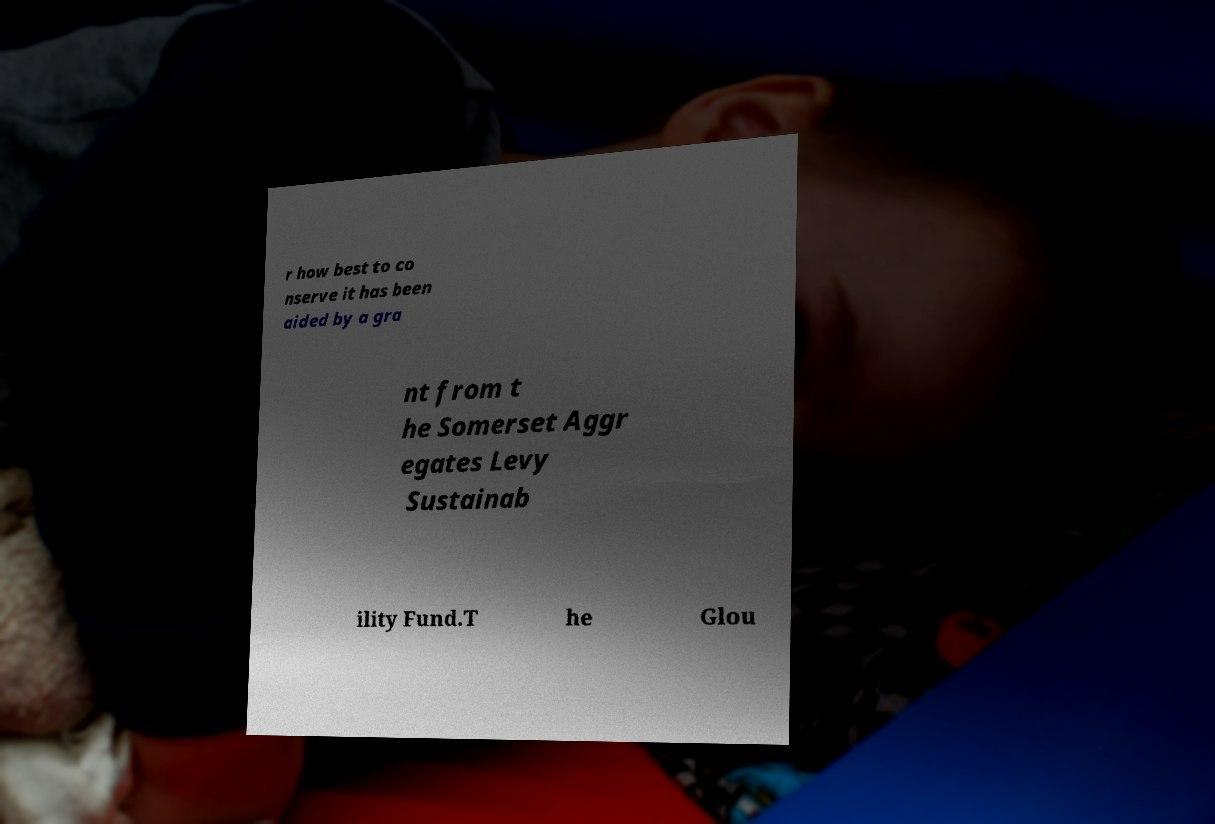What messages or text are displayed in this image? I need them in a readable, typed format. r how best to co nserve it has been aided by a gra nt from t he Somerset Aggr egates Levy Sustainab ility Fund.T he Glou 